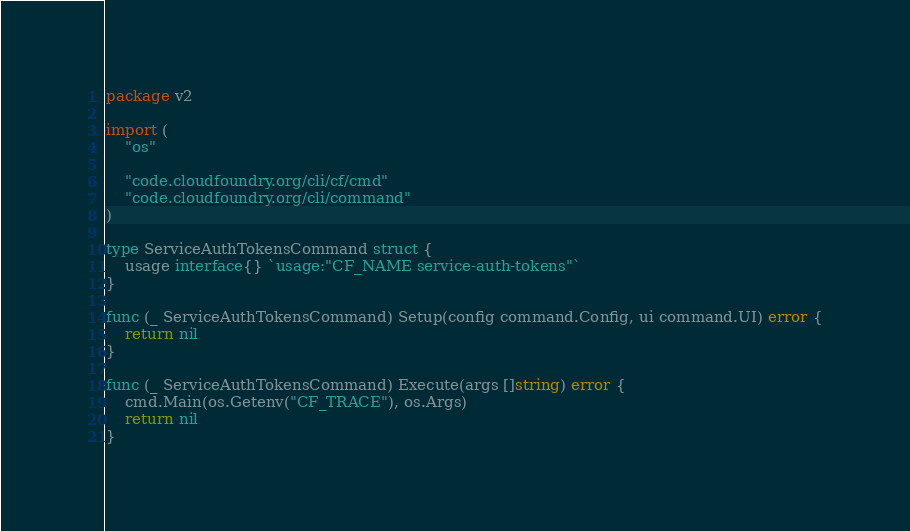<code> <loc_0><loc_0><loc_500><loc_500><_Go_>package v2

import (
	"os"

	"code.cloudfoundry.org/cli/cf/cmd"
	"code.cloudfoundry.org/cli/command"
)

type ServiceAuthTokensCommand struct {
	usage interface{} `usage:"CF_NAME service-auth-tokens"`
}

func (_ ServiceAuthTokensCommand) Setup(config command.Config, ui command.UI) error {
	return nil
}

func (_ ServiceAuthTokensCommand) Execute(args []string) error {
	cmd.Main(os.Getenv("CF_TRACE"), os.Args)
	return nil
}
</code> 